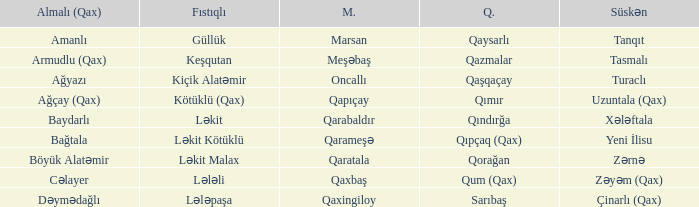What is the Qaxmuğal village with a Fistiqli village keşqutan? Qazmalar. 